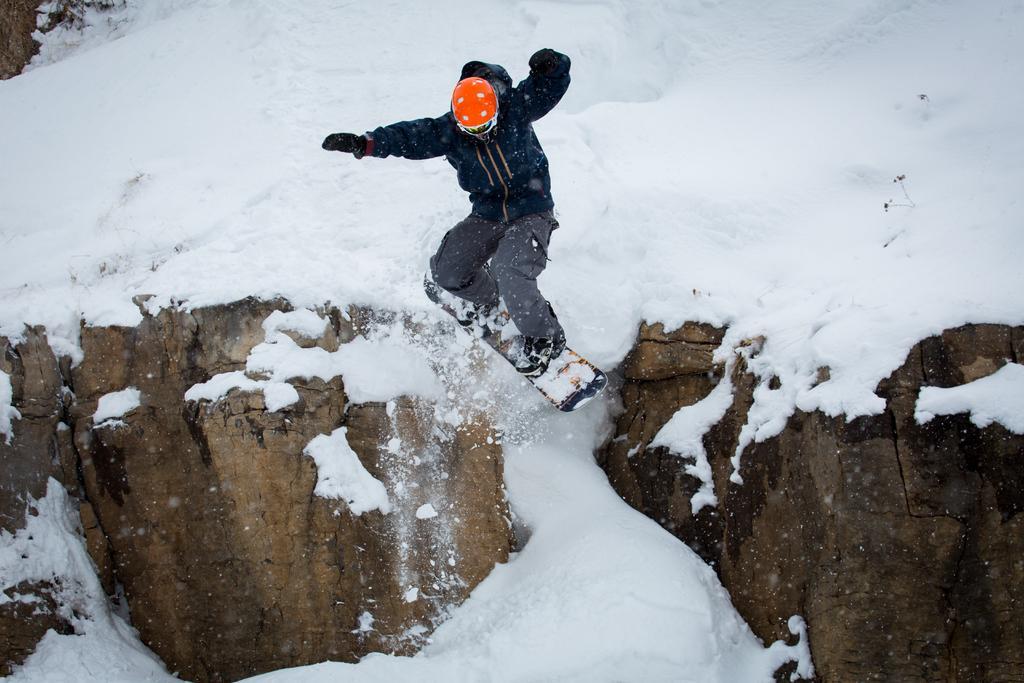Can you describe this image briefly? In this image I can see the person with the ski board. The person is wearing the blue color dress and an orange color helmet. To the side I can see the wooden rock. The person is on the snow. 